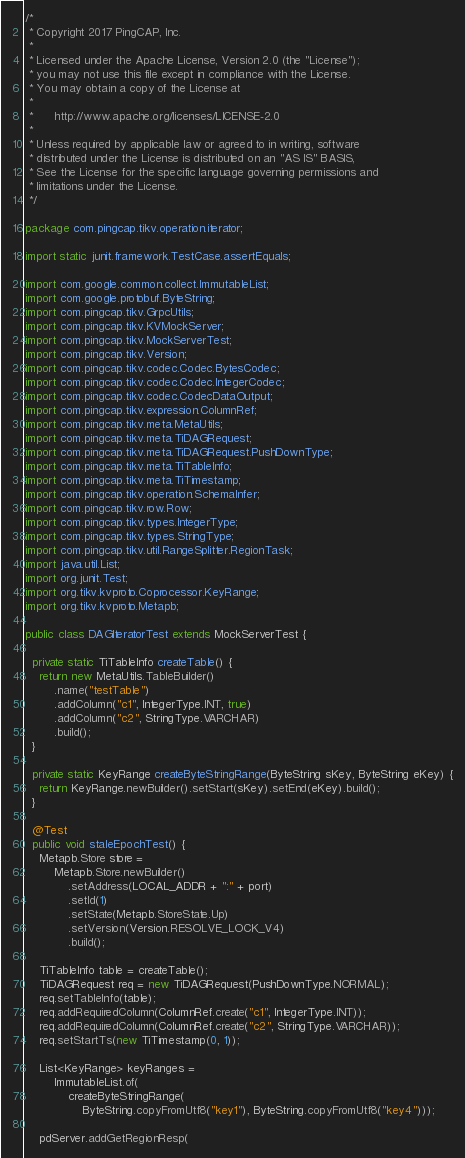Convert code to text. <code><loc_0><loc_0><loc_500><loc_500><_Java_>/*
 * Copyright 2017 PingCAP, Inc.
 *
 * Licensed under the Apache License, Version 2.0 (the "License");
 * you may not use this file except in compliance with the License.
 * You may obtain a copy of the License at
 *
 *      http://www.apache.org/licenses/LICENSE-2.0
 *
 * Unless required by applicable law or agreed to in writing, software
 * distributed under the License is distributed on an "AS IS" BASIS,
 * See the License for the specific language governing permissions and
 * limitations under the License.
 */

package com.pingcap.tikv.operation.iterator;

import static junit.framework.TestCase.assertEquals;

import com.google.common.collect.ImmutableList;
import com.google.protobuf.ByteString;
import com.pingcap.tikv.GrpcUtils;
import com.pingcap.tikv.KVMockServer;
import com.pingcap.tikv.MockServerTest;
import com.pingcap.tikv.Version;
import com.pingcap.tikv.codec.Codec.BytesCodec;
import com.pingcap.tikv.codec.Codec.IntegerCodec;
import com.pingcap.tikv.codec.CodecDataOutput;
import com.pingcap.tikv.expression.ColumnRef;
import com.pingcap.tikv.meta.MetaUtils;
import com.pingcap.tikv.meta.TiDAGRequest;
import com.pingcap.tikv.meta.TiDAGRequest.PushDownType;
import com.pingcap.tikv.meta.TiTableInfo;
import com.pingcap.tikv.meta.TiTimestamp;
import com.pingcap.tikv.operation.SchemaInfer;
import com.pingcap.tikv.row.Row;
import com.pingcap.tikv.types.IntegerType;
import com.pingcap.tikv.types.StringType;
import com.pingcap.tikv.util.RangeSplitter.RegionTask;
import java.util.List;
import org.junit.Test;
import org.tikv.kvproto.Coprocessor.KeyRange;
import org.tikv.kvproto.Metapb;

public class DAGIteratorTest extends MockServerTest {

  private static TiTableInfo createTable() {
    return new MetaUtils.TableBuilder()
        .name("testTable")
        .addColumn("c1", IntegerType.INT, true)
        .addColumn("c2", StringType.VARCHAR)
        .build();
  }

  private static KeyRange createByteStringRange(ByteString sKey, ByteString eKey) {
    return KeyRange.newBuilder().setStart(sKey).setEnd(eKey).build();
  }

  @Test
  public void staleEpochTest() {
    Metapb.Store store =
        Metapb.Store.newBuilder()
            .setAddress(LOCAL_ADDR + ":" + port)
            .setId(1)
            .setState(Metapb.StoreState.Up)
            .setVersion(Version.RESOLVE_LOCK_V4)
            .build();

    TiTableInfo table = createTable();
    TiDAGRequest req = new TiDAGRequest(PushDownType.NORMAL);
    req.setTableInfo(table);
    req.addRequiredColumn(ColumnRef.create("c1", IntegerType.INT));
    req.addRequiredColumn(ColumnRef.create("c2", StringType.VARCHAR));
    req.setStartTs(new TiTimestamp(0, 1));

    List<KeyRange> keyRanges =
        ImmutableList.of(
            createByteStringRange(
                ByteString.copyFromUtf8("key1"), ByteString.copyFromUtf8("key4")));

    pdServer.addGetRegionResp(</code> 